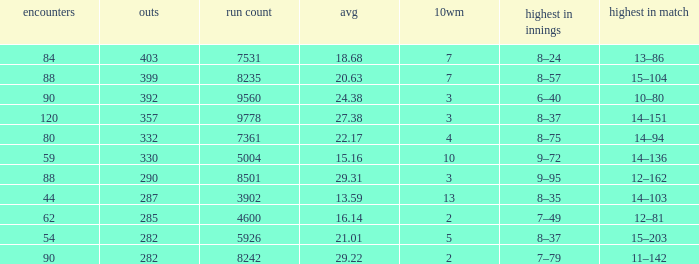How many wickets have runs under 7531, matches over 44, and an average of 22.17? 332.0. 